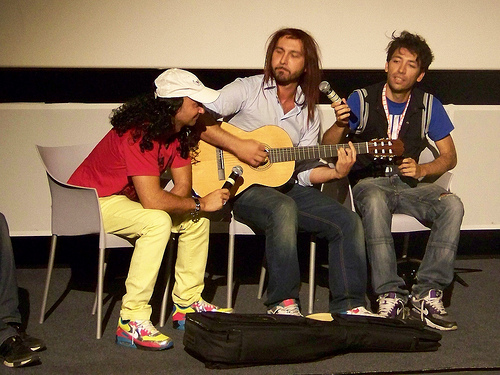<image>
Is there a man above the bag? No. The man is not positioned above the bag. The vertical arrangement shows a different relationship. 